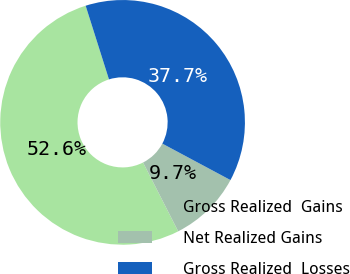Convert chart to OTSL. <chart><loc_0><loc_0><loc_500><loc_500><pie_chart><fcel>Gross Realized  Gains<fcel>Net Realized Gains<fcel>Gross Realized  Losses<nl><fcel>52.63%<fcel>9.67%<fcel>37.7%<nl></chart> 